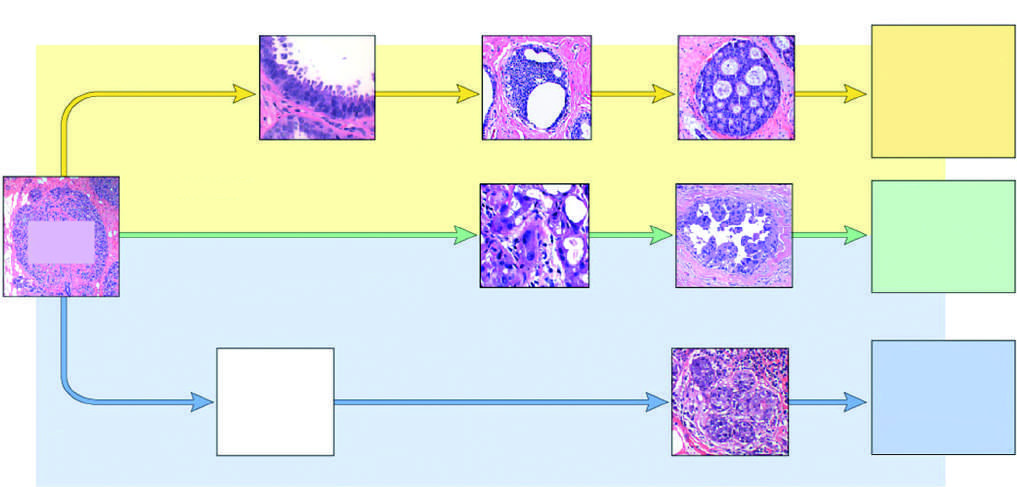re skin stem cells classified as luminal by gene expression profiling?
Answer the question using a single word or phrase. No 